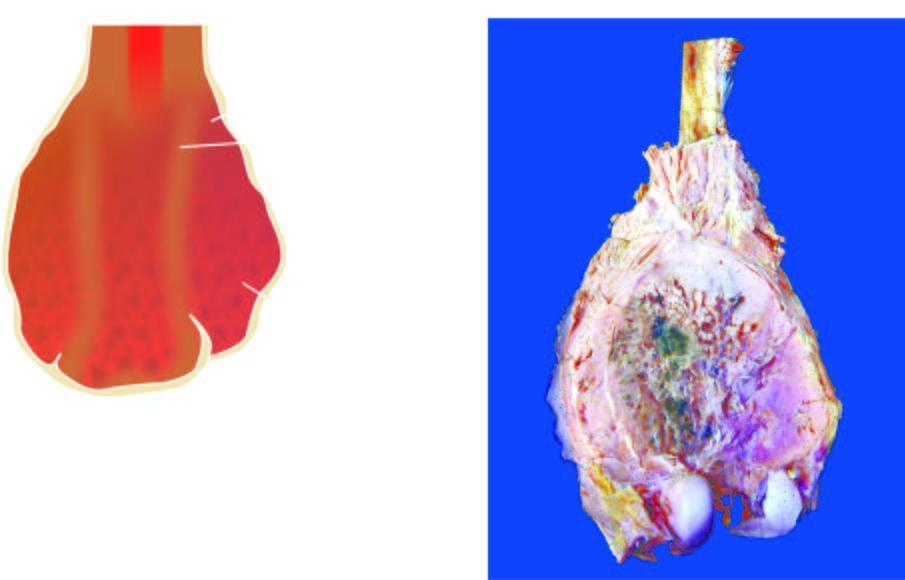what shows a bulky expanded tumour in the region of metaphysis sparing the epiphyseal cartilage?
Answer the question using a single word or phrase. Lower end of the femur 